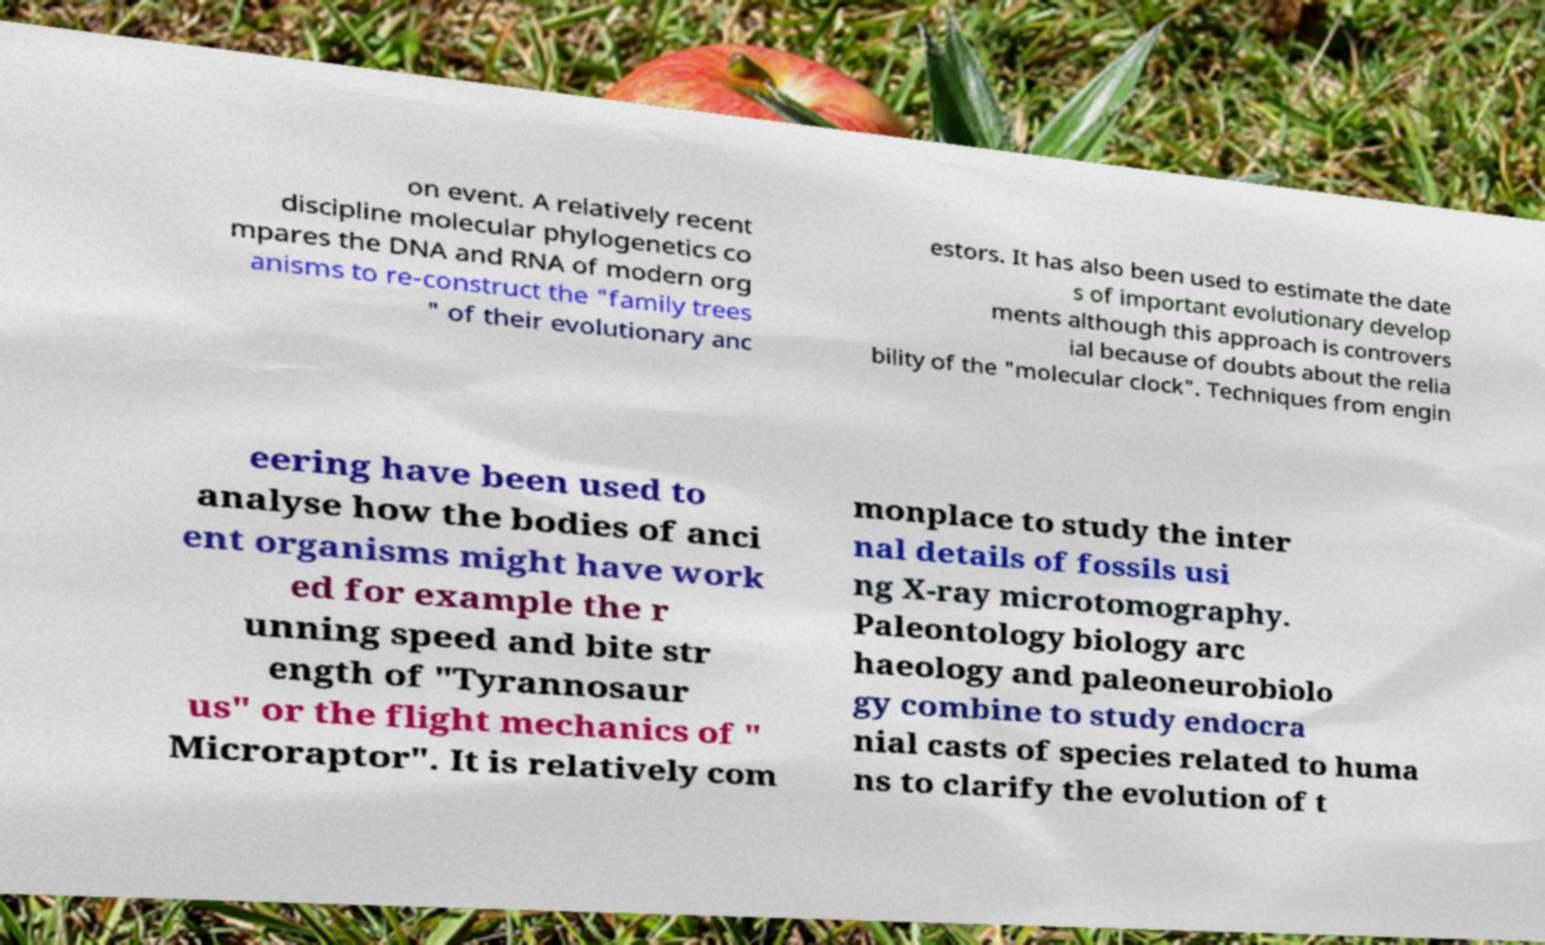What messages or text are displayed in this image? I need them in a readable, typed format. on event. A relatively recent discipline molecular phylogenetics co mpares the DNA and RNA of modern org anisms to re-construct the "family trees " of their evolutionary anc estors. It has also been used to estimate the date s of important evolutionary develop ments although this approach is controvers ial because of doubts about the relia bility of the "molecular clock". Techniques from engin eering have been used to analyse how the bodies of anci ent organisms might have work ed for example the r unning speed and bite str ength of "Tyrannosaur us" or the flight mechanics of " Microraptor". It is relatively com monplace to study the inter nal details of fossils usi ng X-ray microtomography. Paleontology biology arc haeology and paleoneurobiolo gy combine to study endocra nial casts of species related to huma ns to clarify the evolution of t 